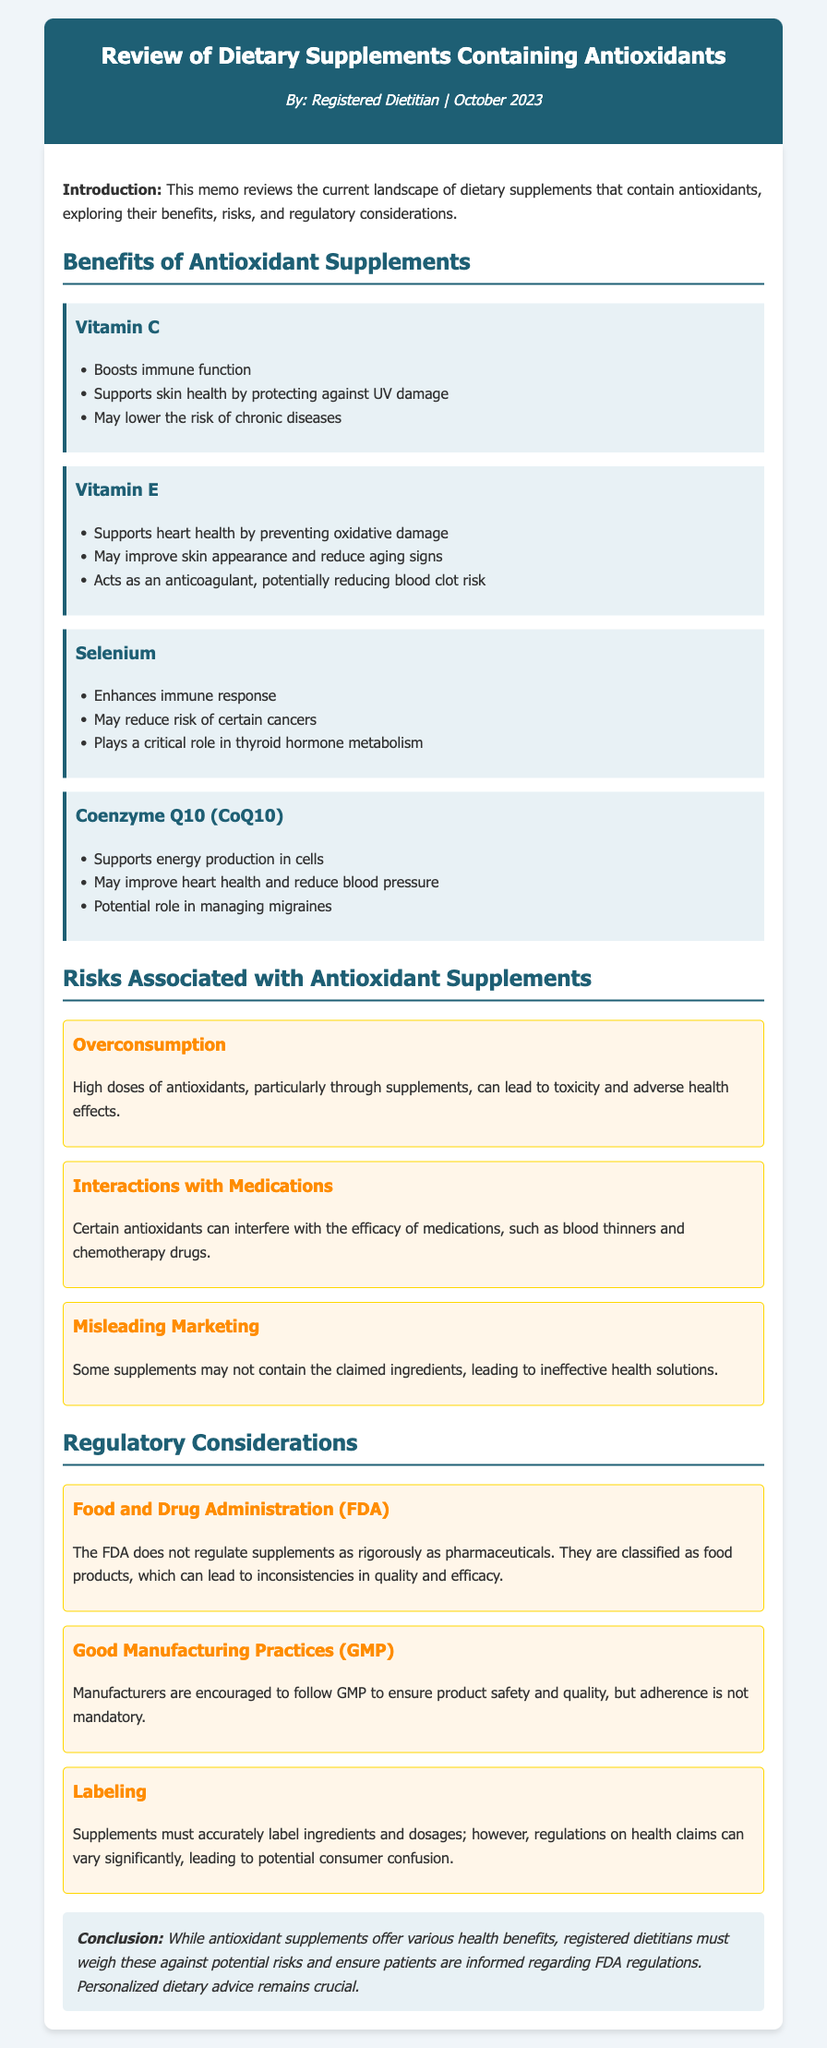What are the main benefits of Vitamin C? The benefits of Vitamin C listed in the document include boosting immune function, supporting skin health by protecting against UV damage, and possibly lowering the risk of chronic diseases.
Answer: Boosts immune function, supports skin health, may lower the risk of chronic diseases What risk is associated with overconsumption of antioxidants? The document states that high doses of antioxidants, particularly through supplements, can lead to toxicity and adverse health effects.
Answer: Toxicity and adverse health effects Which regulatory body is mentioned in relation to dietary supplements? The document refers to the Food and Drug Administration (FDA) when discussing regulatory considerations for dietary supplements.
Answer: Food and Drug Administration (FDA) What role does selenium play according to the memo? The document mentions that selenium enhances immune response, may reduce the risk of certain cancers, and plays a critical role in thyroid hormone metabolism.
Answer: Enhances immune response, may reduce cancer risk, critical role in thyroid hormone metabolism What must supplements accurately label according to regulations? The regulations specify that supplements must accurately label ingredients and dosages, although health claim regulations can vary.
Answer: Ingredients and dosages How many types of risks are associated with antioxidant supplements mentioned in the document? There are three types of risks associated with antioxidant supplements indicated in the document: overconsumption, interactions with medications, and misleading marketing.
Answer: Three What should be adhered to by manufacturers for product safety? The document mentions that manufacturers are encouraged to follow Good Manufacturing Practices (GMP) to ensure product safety and quality, but it is not mandatory.
Answer: Good Manufacturing Practices (GMP) What is the memo's conclusion regarding antioxidant supplements? The conclusion emphasizes that while antioxidant supplements offer health benefits, registered dietitians must weigh these against potential risks and ensure patient information regarding FDA regulations.
Answer: Weigh benefits against risks and ensure patient information regarding FDA regulations 